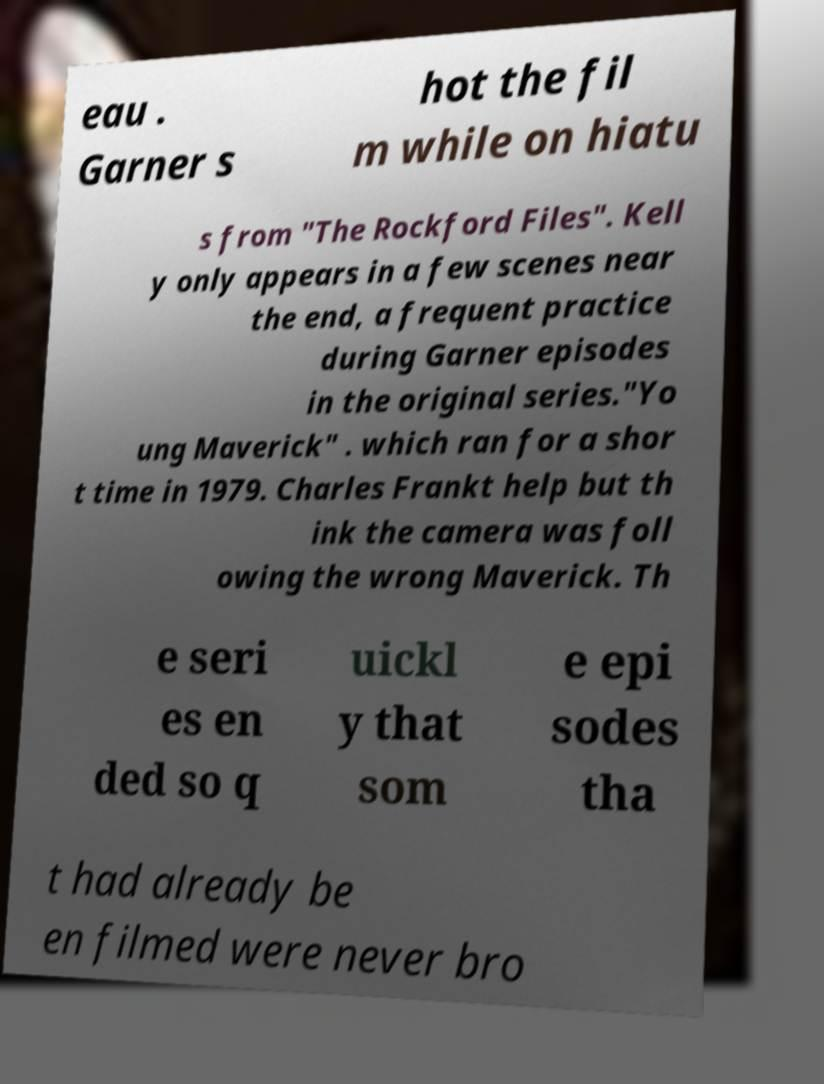For documentation purposes, I need the text within this image transcribed. Could you provide that? eau . Garner s hot the fil m while on hiatu s from "The Rockford Files". Kell y only appears in a few scenes near the end, a frequent practice during Garner episodes in the original series."Yo ung Maverick" . which ran for a shor t time in 1979. Charles Frankt help but th ink the camera was foll owing the wrong Maverick. Th e seri es en ded so q uickl y that som e epi sodes tha t had already be en filmed were never bro 